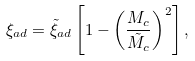Convert formula to latex. <formula><loc_0><loc_0><loc_500><loc_500>\xi _ { a d } = \tilde { \xi } _ { a d } \left [ 1 - \left ( \frac { M _ { c } } { \tilde { M } _ { c } } \right ) ^ { 2 } \right ] ,</formula> 